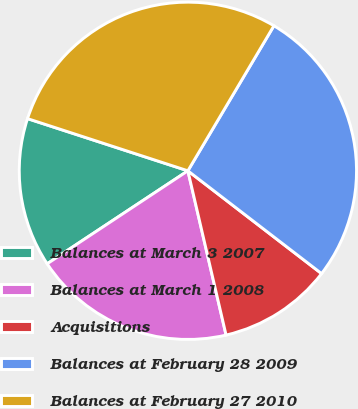<chart> <loc_0><loc_0><loc_500><loc_500><pie_chart><fcel>Balances at March 3 2007<fcel>Balances at March 1 2008<fcel>Acquisitions<fcel>Balances at February 28 2009<fcel>Balances at February 27 2010<nl><fcel>14.3%<fcel>19.34%<fcel>10.93%<fcel>26.91%<fcel>28.51%<nl></chart> 